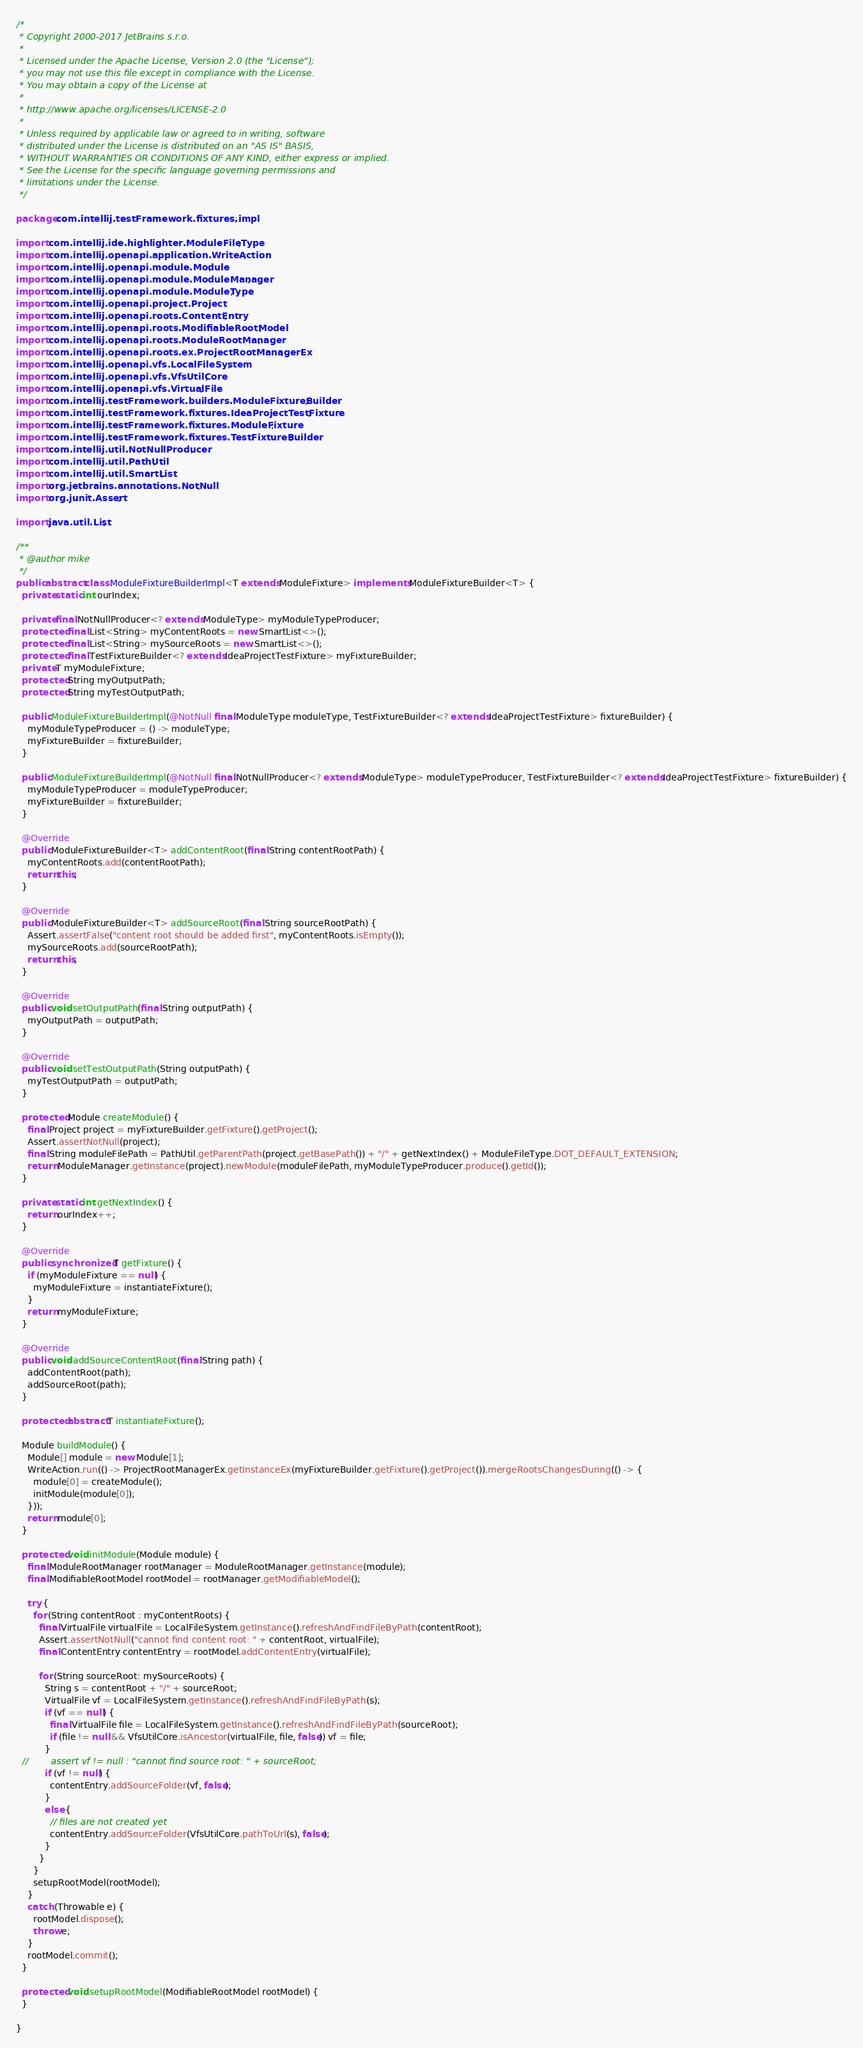<code> <loc_0><loc_0><loc_500><loc_500><_Java_>/*
 * Copyright 2000-2017 JetBrains s.r.o.
 *
 * Licensed under the Apache License, Version 2.0 (the "License");
 * you may not use this file except in compliance with the License.
 * You may obtain a copy of the License at
 *
 * http://www.apache.org/licenses/LICENSE-2.0
 *
 * Unless required by applicable law or agreed to in writing, software
 * distributed under the License is distributed on an "AS IS" BASIS,
 * WITHOUT WARRANTIES OR CONDITIONS OF ANY KIND, either express or implied.
 * See the License for the specific language governing permissions and
 * limitations under the License.
 */

package com.intellij.testFramework.fixtures.impl;

import com.intellij.ide.highlighter.ModuleFileType;
import com.intellij.openapi.application.WriteAction;
import com.intellij.openapi.module.Module;
import com.intellij.openapi.module.ModuleManager;
import com.intellij.openapi.module.ModuleType;
import com.intellij.openapi.project.Project;
import com.intellij.openapi.roots.ContentEntry;
import com.intellij.openapi.roots.ModifiableRootModel;
import com.intellij.openapi.roots.ModuleRootManager;
import com.intellij.openapi.roots.ex.ProjectRootManagerEx;
import com.intellij.openapi.vfs.LocalFileSystem;
import com.intellij.openapi.vfs.VfsUtilCore;
import com.intellij.openapi.vfs.VirtualFile;
import com.intellij.testFramework.builders.ModuleFixtureBuilder;
import com.intellij.testFramework.fixtures.IdeaProjectTestFixture;
import com.intellij.testFramework.fixtures.ModuleFixture;
import com.intellij.testFramework.fixtures.TestFixtureBuilder;
import com.intellij.util.NotNullProducer;
import com.intellij.util.PathUtil;
import com.intellij.util.SmartList;
import org.jetbrains.annotations.NotNull;
import org.junit.Assert;

import java.util.List;

/**
 * @author mike
 */
public abstract class ModuleFixtureBuilderImpl<T extends ModuleFixture> implements ModuleFixtureBuilder<T> {
  private static int ourIndex;

  private final NotNullProducer<? extends ModuleType> myModuleTypeProducer;
  protected final List<String> myContentRoots = new SmartList<>();
  protected final List<String> mySourceRoots = new SmartList<>();
  protected final TestFixtureBuilder<? extends IdeaProjectTestFixture> myFixtureBuilder;
  private T myModuleFixture;
  protected String myOutputPath;
  protected String myTestOutputPath;

  public ModuleFixtureBuilderImpl(@NotNull final ModuleType moduleType, TestFixtureBuilder<? extends IdeaProjectTestFixture> fixtureBuilder) {
    myModuleTypeProducer = () -> moduleType;
    myFixtureBuilder = fixtureBuilder;
  }

  public ModuleFixtureBuilderImpl(@NotNull final NotNullProducer<? extends ModuleType> moduleTypeProducer, TestFixtureBuilder<? extends IdeaProjectTestFixture> fixtureBuilder) {
    myModuleTypeProducer = moduleTypeProducer;
    myFixtureBuilder = fixtureBuilder;
  }

  @Override
  public ModuleFixtureBuilder<T> addContentRoot(final String contentRootPath) {
    myContentRoots.add(contentRootPath);
    return this;
  }

  @Override
  public ModuleFixtureBuilder<T> addSourceRoot(final String sourceRootPath) {
    Assert.assertFalse("content root should be added first", myContentRoots.isEmpty());
    mySourceRoots.add(sourceRootPath);
    return this;
  }

  @Override
  public void setOutputPath(final String outputPath) {
    myOutputPath = outputPath;
  }

  @Override
  public void setTestOutputPath(String outputPath) {
    myTestOutputPath = outputPath;
  }

  protected Module createModule() {
    final Project project = myFixtureBuilder.getFixture().getProject();
    Assert.assertNotNull(project);
    final String moduleFilePath = PathUtil.getParentPath(project.getBasePath()) + "/" + getNextIndex() + ModuleFileType.DOT_DEFAULT_EXTENSION;
    return ModuleManager.getInstance(project).newModule(moduleFilePath, myModuleTypeProducer.produce().getId());
  }

  private static int getNextIndex() {
    return ourIndex++;
  }

  @Override
  public synchronized T getFixture() {
    if (myModuleFixture == null) {
      myModuleFixture = instantiateFixture();
    }
    return myModuleFixture;
  }

  @Override
  public void addSourceContentRoot(final String path) {
    addContentRoot(path);
    addSourceRoot(path);
  }

  protected abstract T instantiateFixture();

  Module buildModule() {
    Module[] module = new Module[1];
    WriteAction.run(() -> ProjectRootManagerEx.getInstanceEx(myFixtureBuilder.getFixture().getProject()).mergeRootsChangesDuring(() -> {
      module[0] = createModule();
      initModule(module[0]);
    }));
    return module[0];
  }

  protected void initModule(Module module) {
    final ModuleRootManager rootManager = ModuleRootManager.getInstance(module);
    final ModifiableRootModel rootModel = rootManager.getModifiableModel();

    try {
      for (String contentRoot : myContentRoots) {
        final VirtualFile virtualFile = LocalFileSystem.getInstance().refreshAndFindFileByPath(contentRoot);
        Assert.assertNotNull("cannot find content root: " + contentRoot, virtualFile);
        final ContentEntry contentEntry = rootModel.addContentEntry(virtualFile);

        for (String sourceRoot: mySourceRoots) {
          String s = contentRoot + "/" + sourceRoot;
          VirtualFile vf = LocalFileSystem.getInstance().refreshAndFindFileByPath(s);
          if (vf == null) {
            final VirtualFile file = LocalFileSystem.getInstance().refreshAndFindFileByPath(sourceRoot);
            if (file != null && VfsUtilCore.isAncestor(virtualFile, file, false)) vf = file;
          }
  //        assert vf != null : "cannot find source root: " + sourceRoot;
          if (vf != null) {
            contentEntry.addSourceFolder(vf, false);
          }
          else {
            // files are not created yet
            contentEntry.addSourceFolder(VfsUtilCore.pathToUrl(s), false);
          }
        }
      }
      setupRootModel(rootModel);
    }
    catch (Throwable e) {
      rootModel.dispose();
      throw e;
    }
    rootModel.commit();
  }

  protected void setupRootModel(ModifiableRootModel rootModel) {
  }

}
</code> 